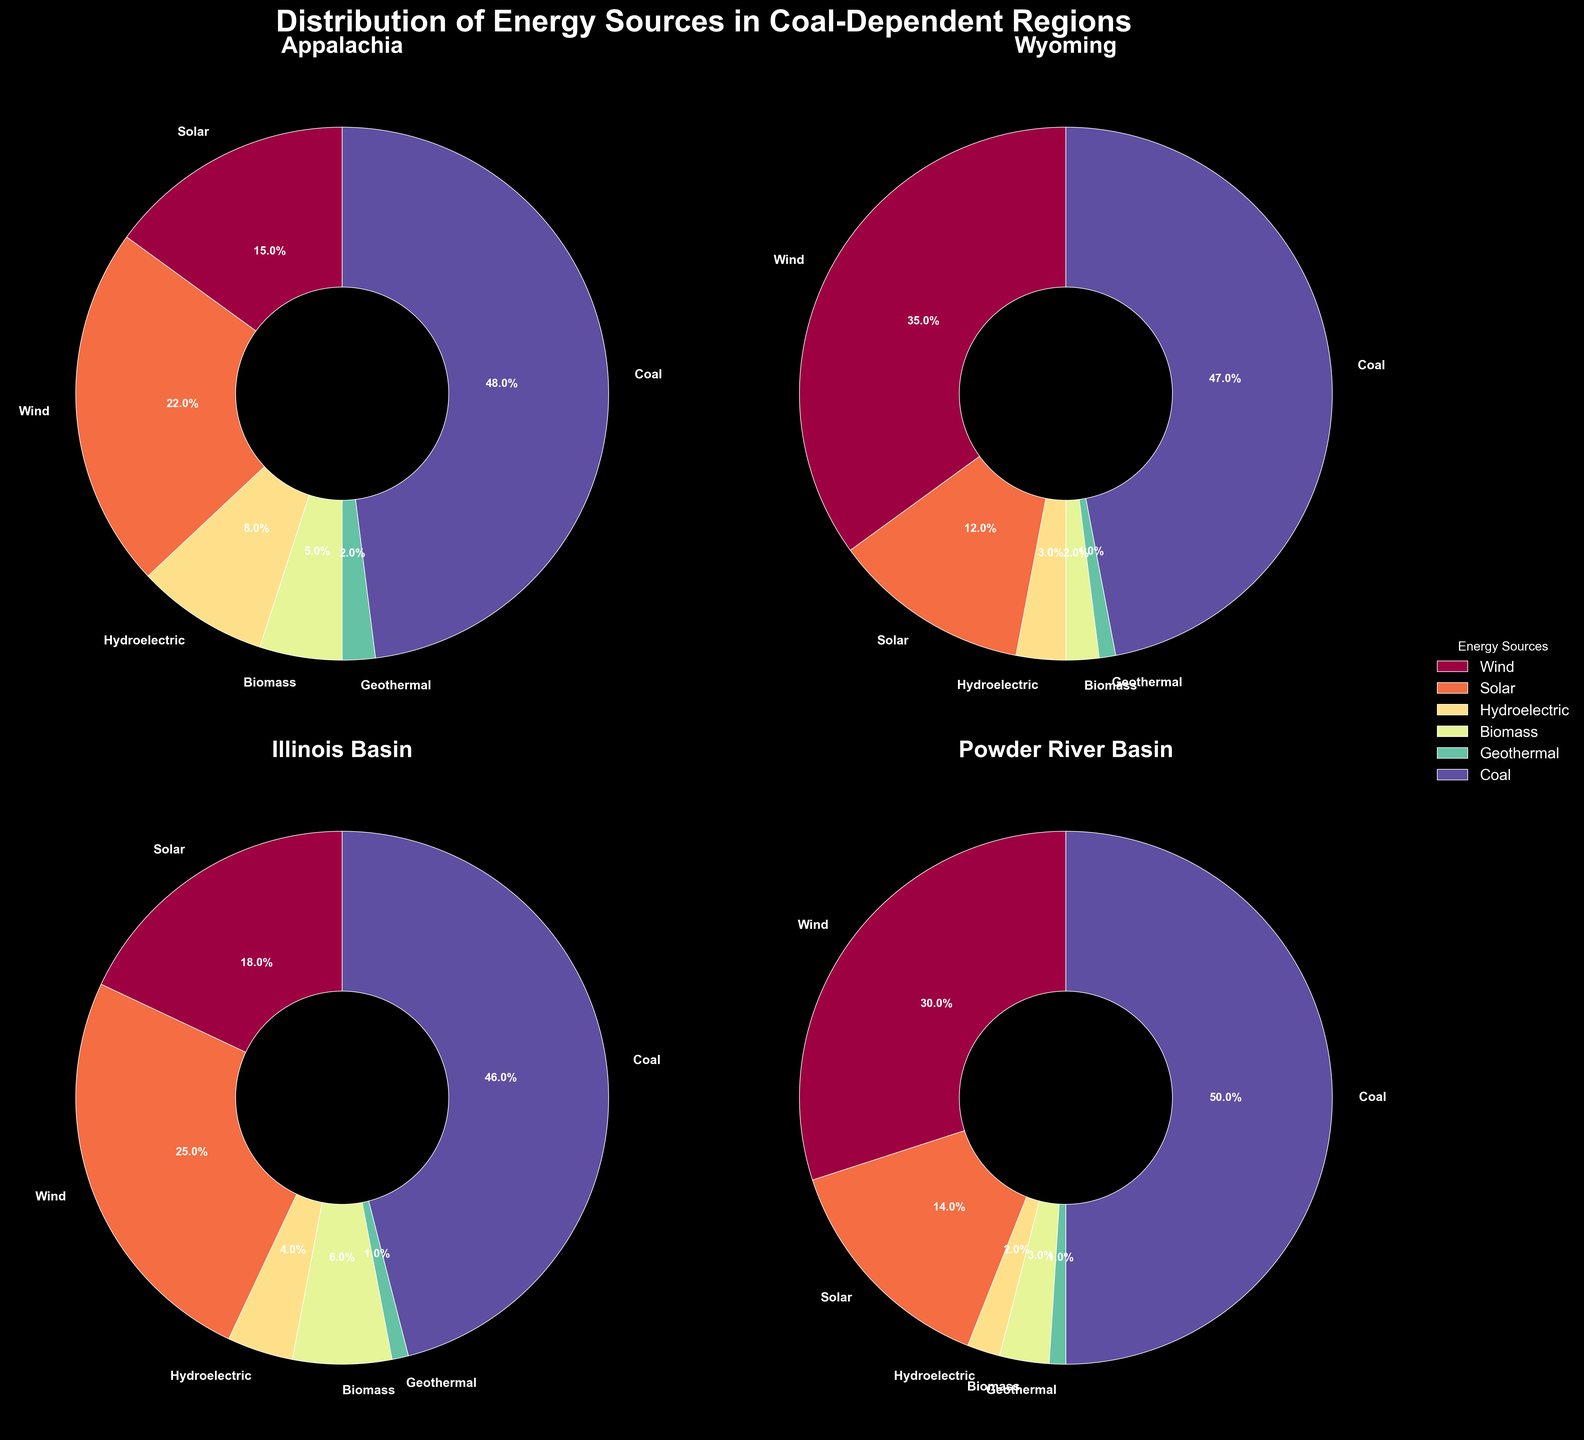What is the percentage difference in wind energy usage between Wyoming and Illinois Basin? To find the difference, subtract the percentage of wind energy in Illinois Basin (25%) from the percentage in Wyoming (35%). Calculation: 35% - 25% = 10%.
Answer: 10% Which region has the highest solar energy percentage? Examine the pie charts for each region and compare the solar energy percentages: Appalachia (15%), Wyoming (12%), Illinois Basin (18%), Powder River Basin (14%). The highest is Illinois Basin with 18%.
Answer: Illinois Basin Among the listed regions, which one has the smallest share of biomass energy? Compare the biomass energy percentages: Appalachia (5%), Wyoming (2%), Illinois Basin (6%), Powder River Basin (3%). The smallest is Wyoming with 2%.
Answer: Wyoming How does the percentage of hydroelectric energy in Powder River Basin compare to that in Appalachia? Compare hydroelectric percentages in the two regions: Powder River Basin (2%) and Appalachia (8%). Appalachian percentage is higher.
Answer: Appalachia If coal energy were reduced by 10% in Wyoming, what would be the new coal percentage? Subtract 10% from Wyoming’s current coal percentage (47%). Calculation: 47% - 10% = 37%.
Answer: 37% Is the share of renewable energy higher in Wyoming or the Powder River Basin, and by how much? Calculate the renewable energy percentage in each region by subtracting the coal percentage from 100%. Wyoming: 100% - 47% = 53%. Powder River Basin: 100% - 50% = 50%. Compare the two: 53% - 50% = 3%.
Answer: Wyoming by 3% What is the combined percentage of solar and wind energy in Appalachia? Add the percentages of solar (15%) and wind (22%) in Appalachia. Calculation: 15% + 22% = 37%.
Answer: 37% Which region has the smallest share of geothermal energy, and what is it? Compare the geothermal energy percentages: Appalachian (2%), Wyoming (1%), Illinois Basin (1%), Powder River Basin (1%). All but Appalachian regions have 1%.
Answer: Wyoming, Illinois Basin, and Powder River Basin (1%) How many regions have a coal percentage higher than 45%? Review the coal percentages: Appalachia (48%), Wyoming (47%), Illinois Basin (46%), Powder River Basin (50%). All four regions have percentages higher than 45%.
Answer: 4 regions 